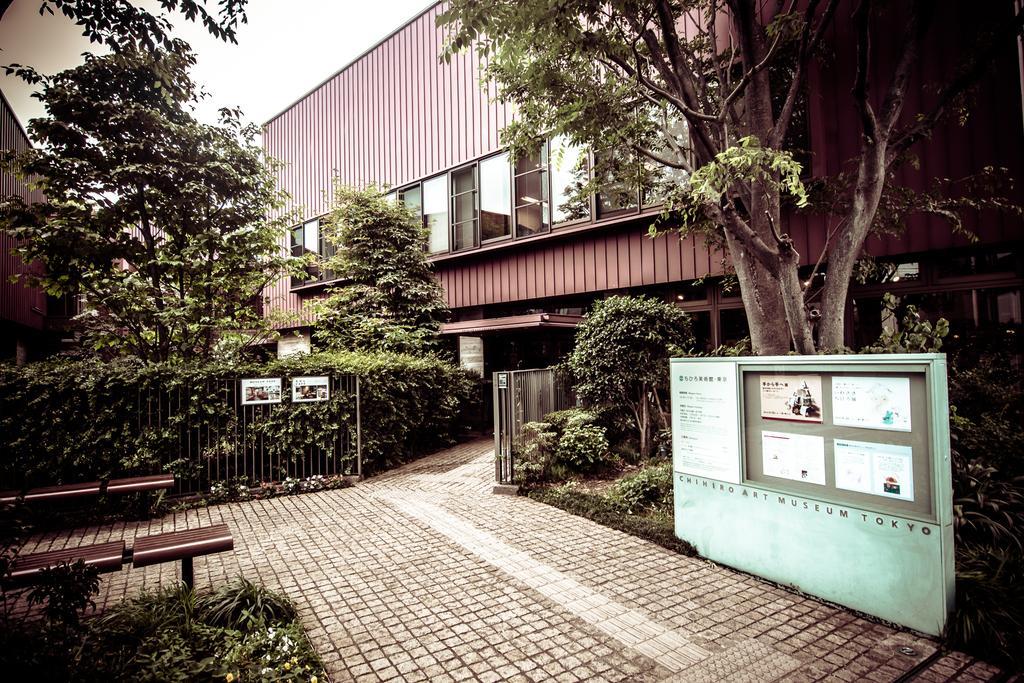In one or two sentences, can you explain what this image depicts? In this image I can see the railing and few boards attached to it, few trees in green color. In the background I can see the shed, few glass windows and the sky is in white color. 